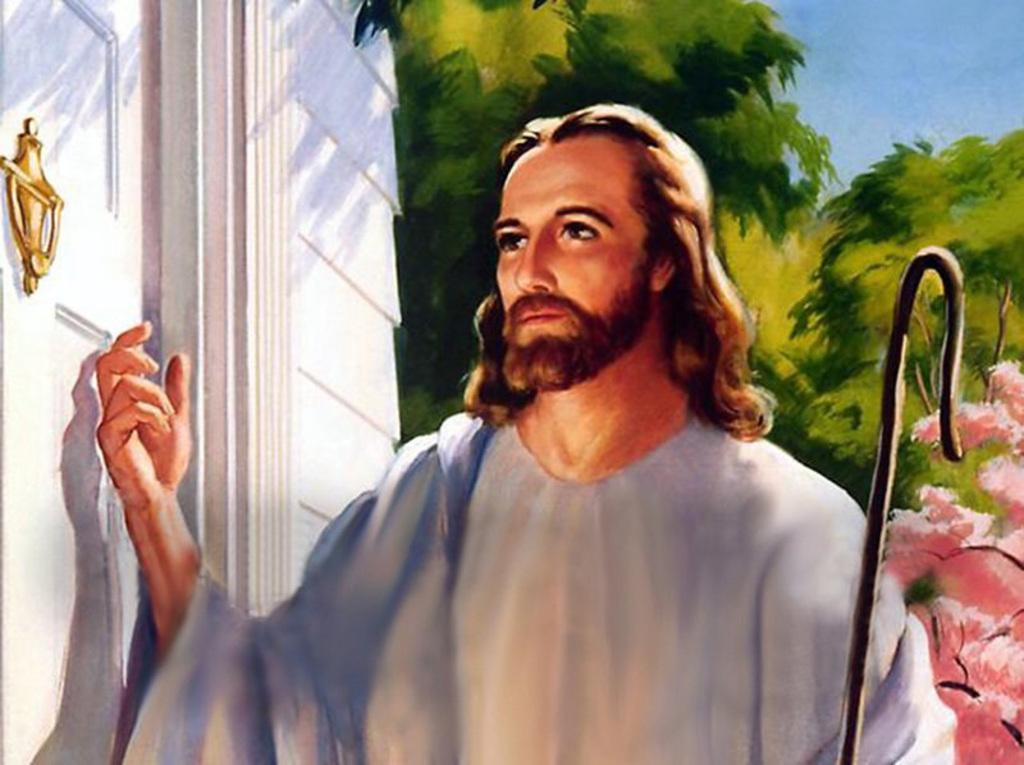Please provide a concise description of this image. In this picture I can see the painting. I can see a person in it. I can see trees. I can see a door. 